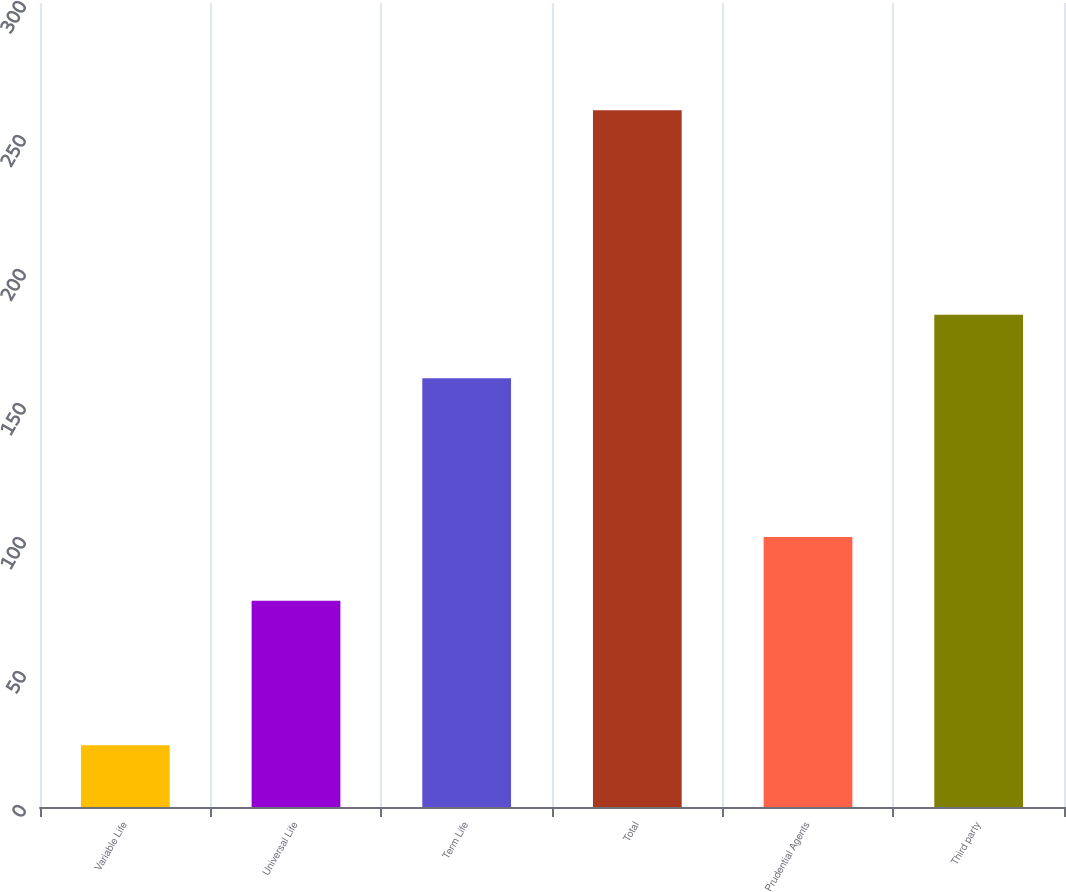<chart> <loc_0><loc_0><loc_500><loc_500><bar_chart><fcel>Variable Life<fcel>Universal Life<fcel>Term Life<fcel>Total<fcel>Prudential Agents<fcel>Third party<nl><fcel>23<fcel>77<fcel>160<fcel>260<fcel>100.7<fcel>183.7<nl></chart> 